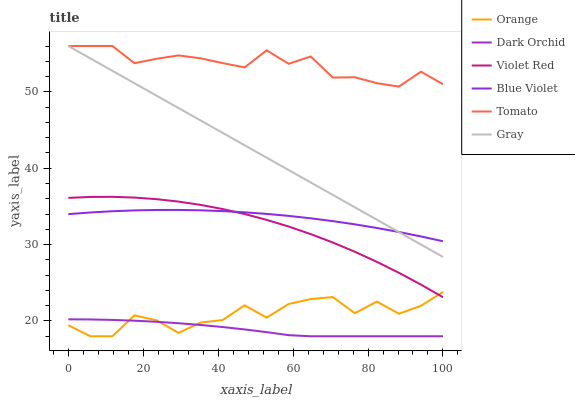Does Dark Orchid have the minimum area under the curve?
Answer yes or no. Yes. Does Tomato have the maximum area under the curve?
Answer yes or no. Yes. Does Gray have the minimum area under the curve?
Answer yes or no. No. Does Gray have the maximum area under the curve?
Answer yes or no. No. Is Gray the smoothest?
Answer yes or no. Yes. Is Orange the roughest?
Answer yes or no. Yes. Is Violet Red the smoothest?
Answer yes or no. No. Is Violet Red the roughest?
Answer yes or no. No. Does Dark Orchid have the lowest value?
Answer yes or no. Yes. Does Gray have the lowest value?
Answer yes or no. No. Does Gray have the highest value?
Answer yes or no. Yes. Does Violet Red have the highest value?
Answer yes or no. No. Is Orange less than Gray?
Answer yes or no. Yes. Is Gray greater than Violet Red?
Answer yes or no. Yes. Does Violet Red intersect Orange?
Answer yes or no. Yes. Is Violet Red less than Orange?
Answer yes or no. No. Is Violet Red greater than Orange?
Answer yes or no. No. Does Orange intersect Gray?
Answer yes or no. No. 